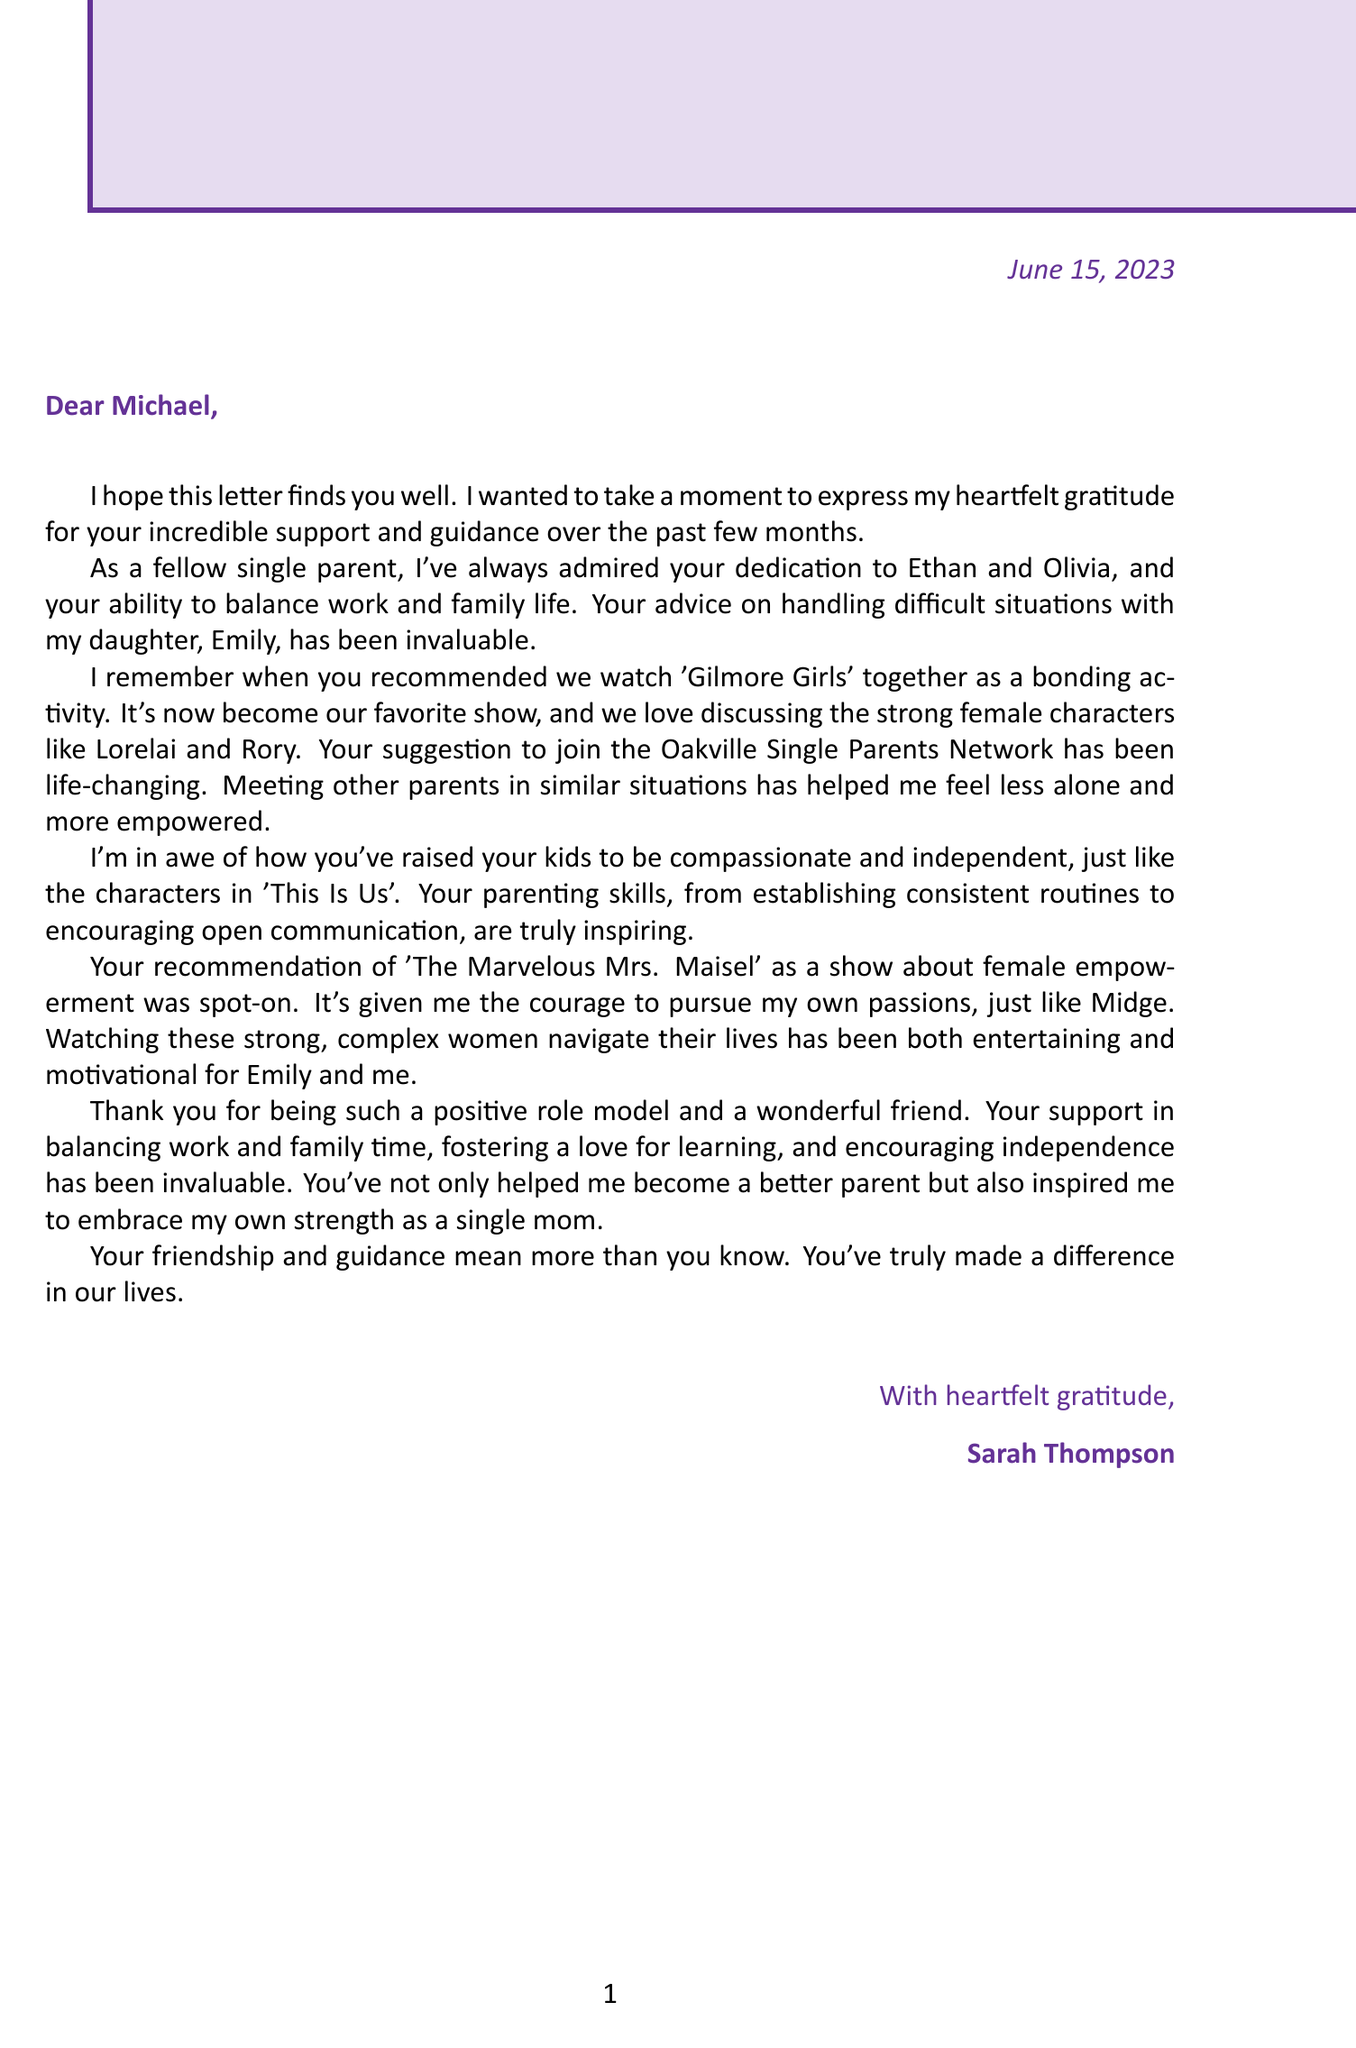What is the sender's name? The sender's name is mentioned at the end of the letter as the person who expressed gratitude.
Answer: Sarah Thompson What is the recipient's name? The recipient's name is indicated in the salutation at the beginning of the letter.
Answer: Michael What is the favorite show mentioned? The letter discusses a bonding activity that involves watching a specific show together.
Answer: Gilmore Girls How many children does the sender have? The letter references the sender's daughter, which indicates the number of children she has.
Answer: 1 What is the support group mentioned in the letter? The letter includes the name of the support group recommended by the recipient.
Answer: Oakville Single Parents Network What themes are highlighted in 'The Marvelous Mrs. Maisel'? The letter refers to the themes present in the recommended show, emphasizing female empowerment.
Answer: Female empowerment What positive impact did the support group have? The letter describes how the support group affected the sender's feelings regarding her situation.
Answer: Life-changing How did the viewer feel about 'This Is Us'? The letter expresses admiration for how the recipient's children were raised, compared to characters in a specific show.
Answer: In awe What relationship is discussed in 'Gilmore Girls'? The letter mentions this show and brings attention to a specific relationship depicted in it.
Answer: Mother-daughter relationship 